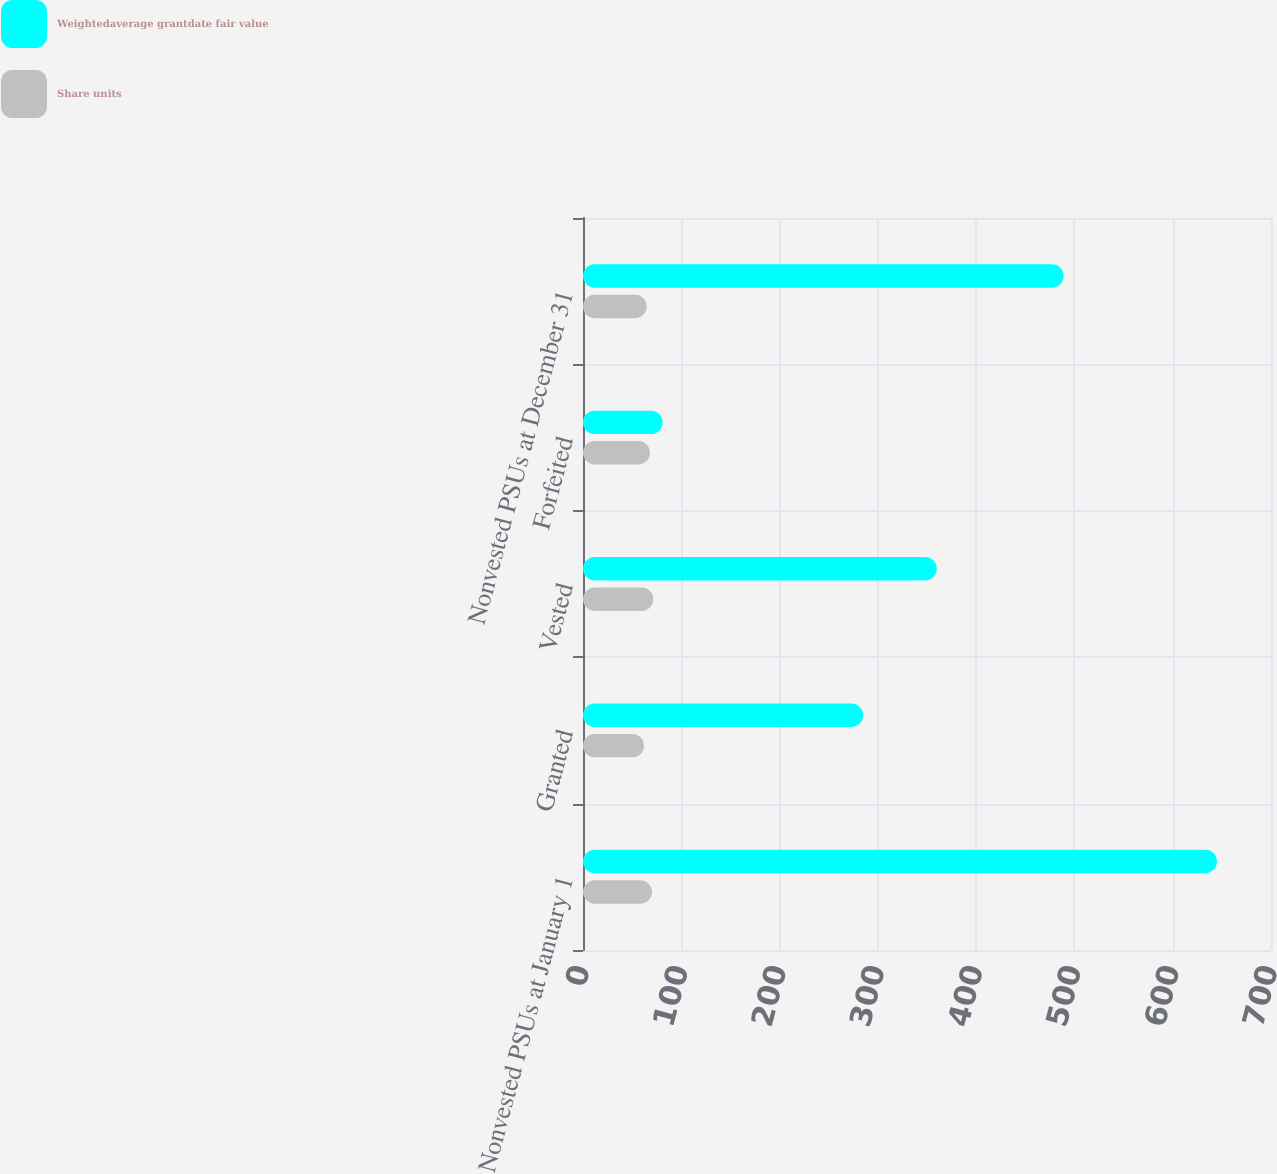<chart> <loc_0><loc_0><loc_500><loc_500><stacked_bar_chart><ecel><fcel>Nonvested PSUs at January 1<fcel>Granted<fcel>Vested<fcel>Forfeited<fcel>Nonvested PSUs at December 31<nl><fcel>Weightedaverage grantdate fair value<fcel>645<fcel>285<fcel>360<fcel>81<fcel>489<nl><fcel>Share units<fcel>70.18<fcel>62.08<fcel>71.51<fcel>68.16<fcel>64.8<nl></chart> 